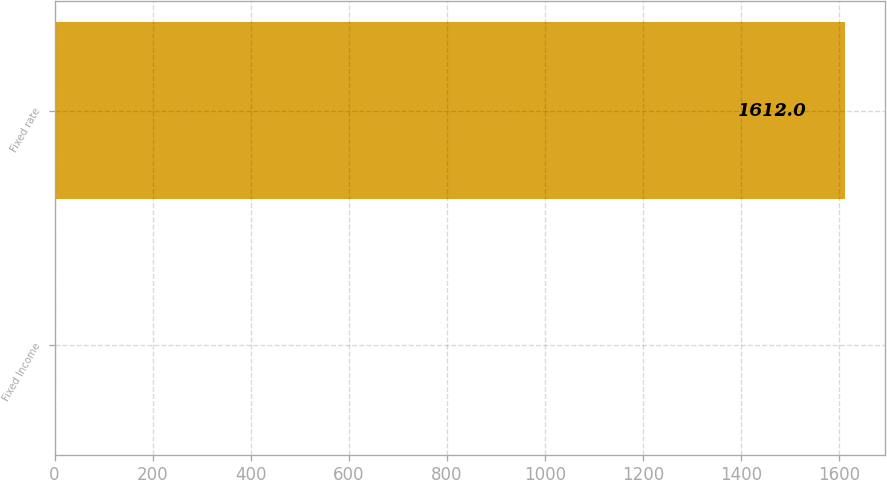<chart> <loc_0><loc_0><loc_500><loc_500><bar_chart><fcel>Fixed Income<fcel>Fixed rate<nl><fcel>2<fcel>1612<nl></chart> 